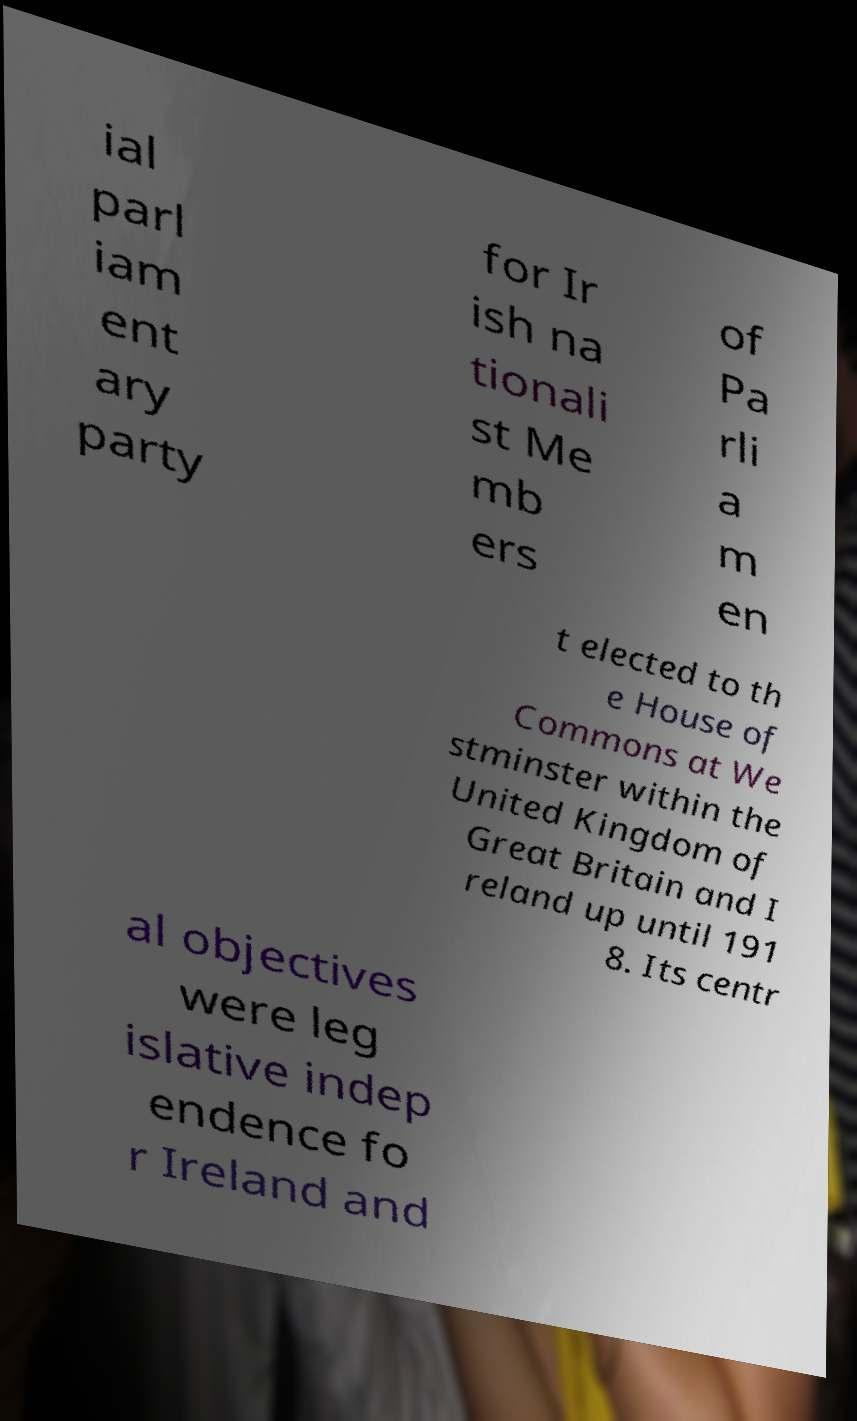I need the written content from this picture converted into text. Can you do that? ial parl iam ent ary party for Ir ish na tionali st Me mb ers of Pa rli a m en t elected to th e House of Commons at We stminster within the United Kingdom of Great Britain and I reland up until 191 8. Its centr al objectives were leg islative indep endence fo r Ireland and 